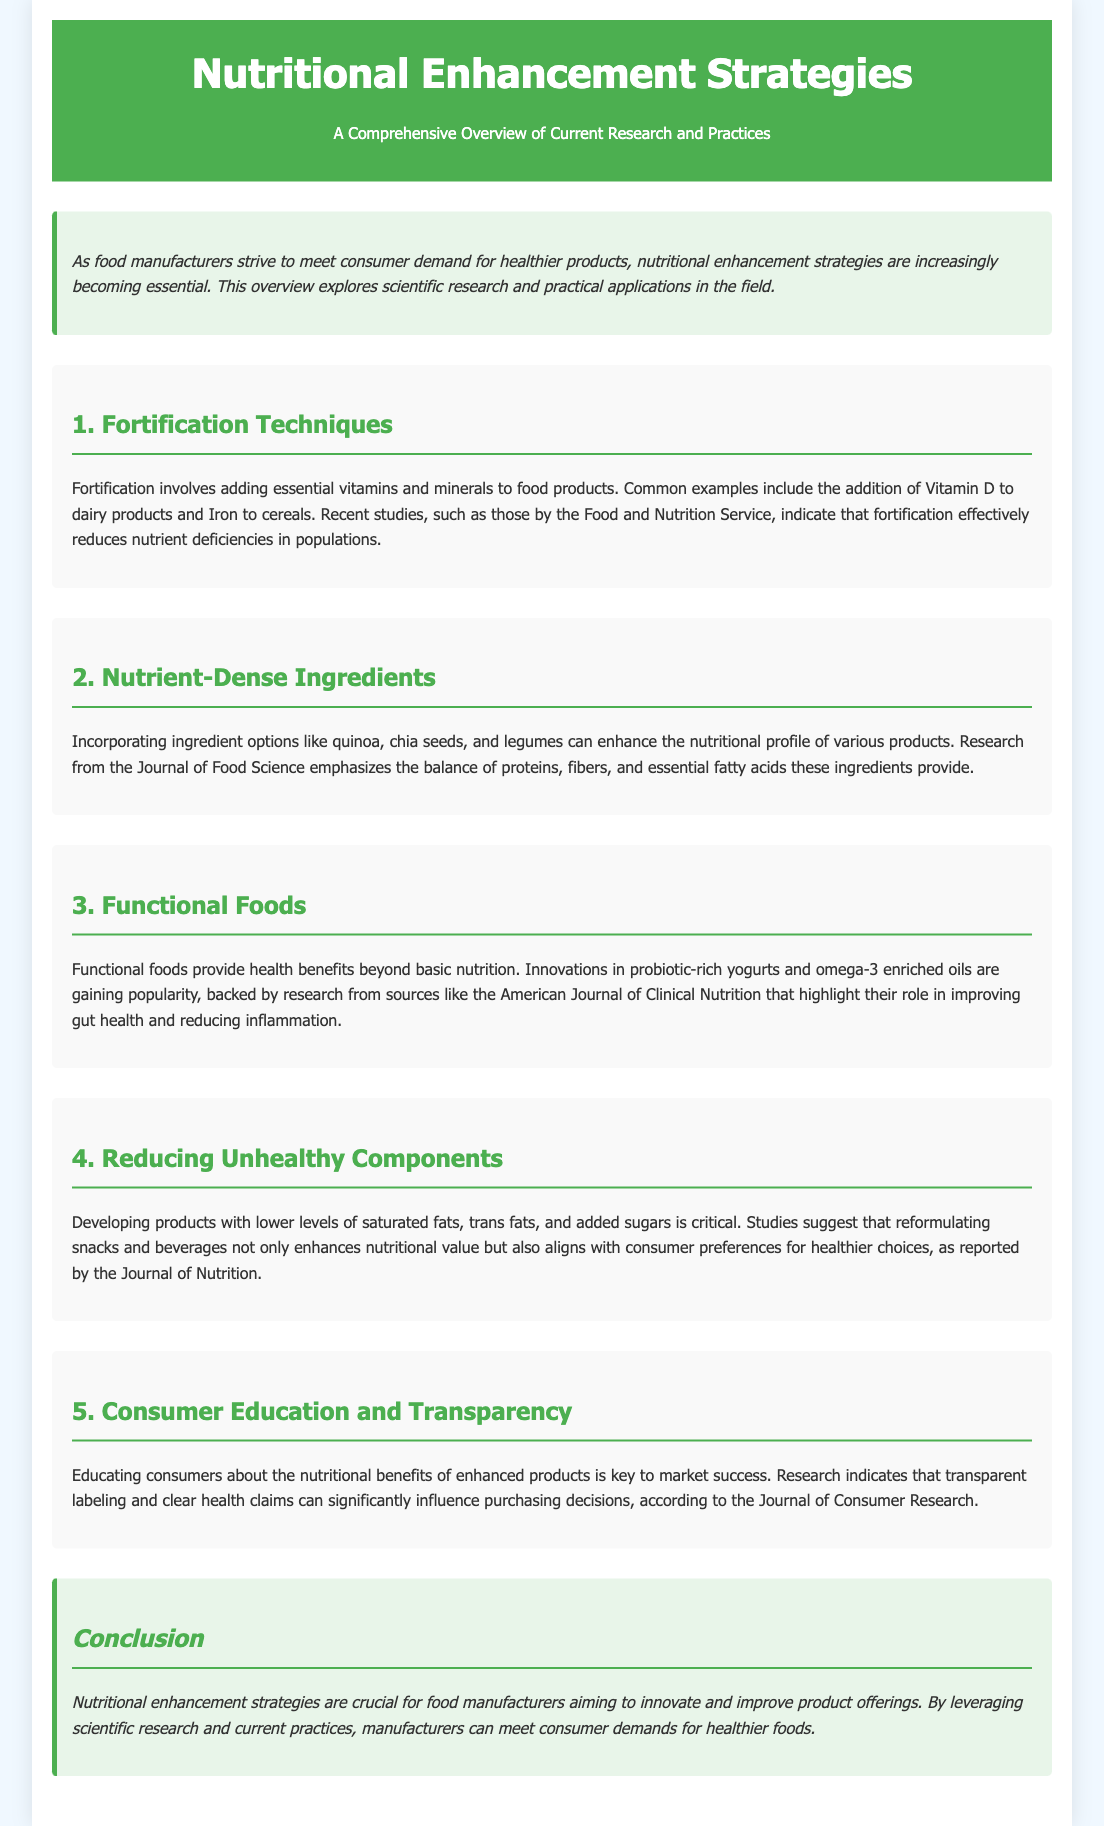What are examples of nutrients added in fortification? The document specifically mentions Vitamin D and Iron as common examples used in fortification.
Answer: Vitamin D, Iron Which food ingredients are suggested to enhance nutritional profile? The document lists quinoa, chia seeds, and legumes as nutrient-dense ingredients.
Answer: Quinoa, chia seeds, legumes What is a health benefit of functional foods mentioned? The document states that functional foods provide health benefits beyond basic nutrition, specifically mentioning gut health and reducing inflammation.
Answer: Gut health, reducing inflammation What unhealthy components should be reduced in products? The document highlights the need to lower saturated fats, trans fats, and added sugars in food products.
Answer: Saturated fats, trans fats, added sugars What influences purchasing decisions according to consumer education? The document indicates that transparent labeling and clear health claims can significantly influence consumer purchasing decisions.
Answer: Transparent labeling, clear health claims How does fortification affect nutrient deficiencies? The document references studies indicating that fortification effectively reduces nutrient deficiencies in populations.
Answer: Reduces nutrient deficiencies Which publication discussed the balance of proteins, fibers, and essential fatty acids? The document mentions that research from the Journal of Food Science discusses the balance provided by nutrient-dense ingredients.
Answer: Journal of Food Science What is a key strategy for food manufacturers to improve product offerings? The document states that leveraging scientific research and current practices is crucial for food manufacturers to innovate and improve their products.
Answer: Leveraging scientific research 